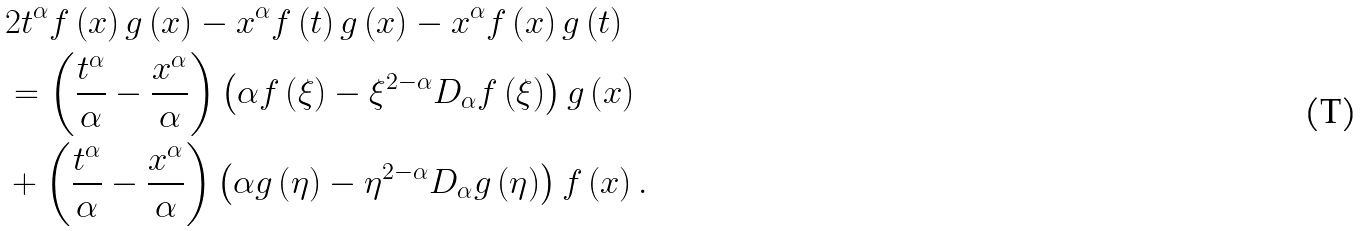Convert formula to latex. <formula><loc_0><loc_0><loc_500><loc_500>& 2 t ^ { \alpha } f \left ( x \right ) g \left ( x \right ) - x ^ { \alpha } f \left ( t \right ) g \left ( x \right ) - x ^ { \alpha } f \left ( x \right ) g \left ( t \right ) \\ & = \left ( { \frac { t ^ { \alpha } } { \alpha } - \frac { x ^ { \alpha } } { \alpha } } \right ) \left ( { \alpha f \left ( \xi \right ) - \xi ^ { 2 - \alpha } D _ { \alpha } f \left ( \xi \right ) } \right ) g \left ( x \right ) \\ & + \left ( { \frac { t ^ { \alpha } } { \alpha } - \frac { x ^ { \alpha } } { \alpha } } \right ) \left ( { \alpha g \left ( \eta \right ) - \eta ^ { 2 - \alpha } D _ { \alpha } g \left ( \eta \right ) } \right ) f \left ( x \right ) .</formula> 